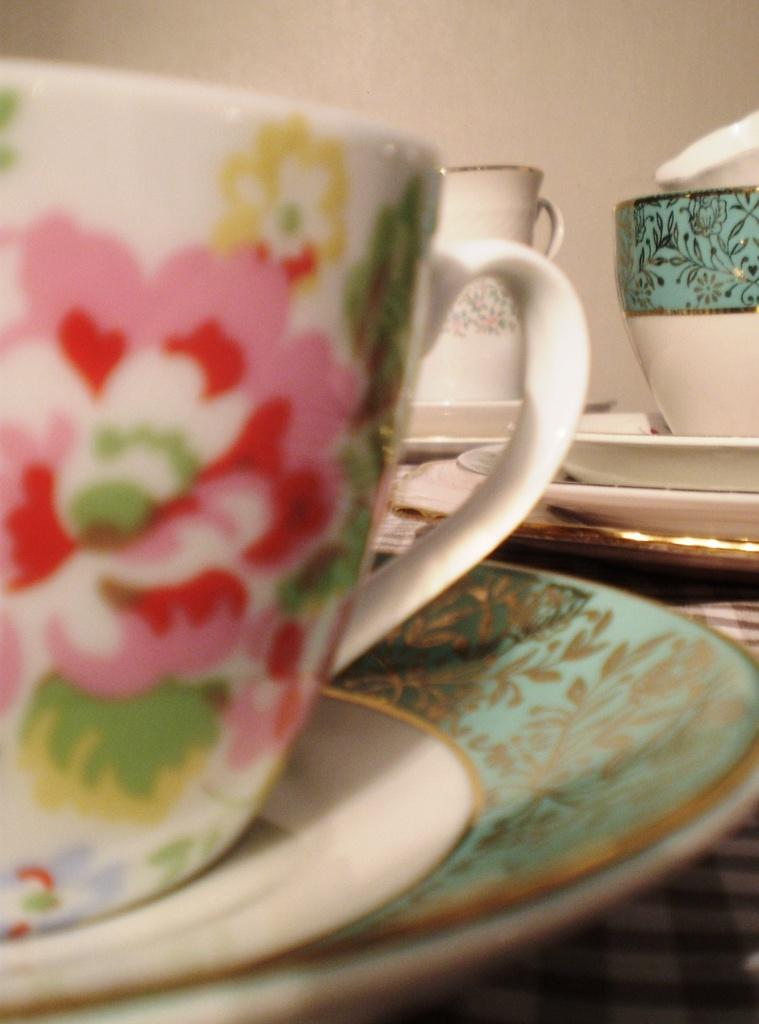What type of dishware can be seen in the image? There are cups and saucers in the image. What is the cups and saucers placed on? The cups and saucers are on a brown and white color cloth. What can be seen in the background of the image? There is a wall visible in the background of the image. What type of ray is swimming in the image? There is no ray present in the image; it features cups, saucers, and a background wall. What song is being played in the image? There is no indication of any music or song being played in the image. 